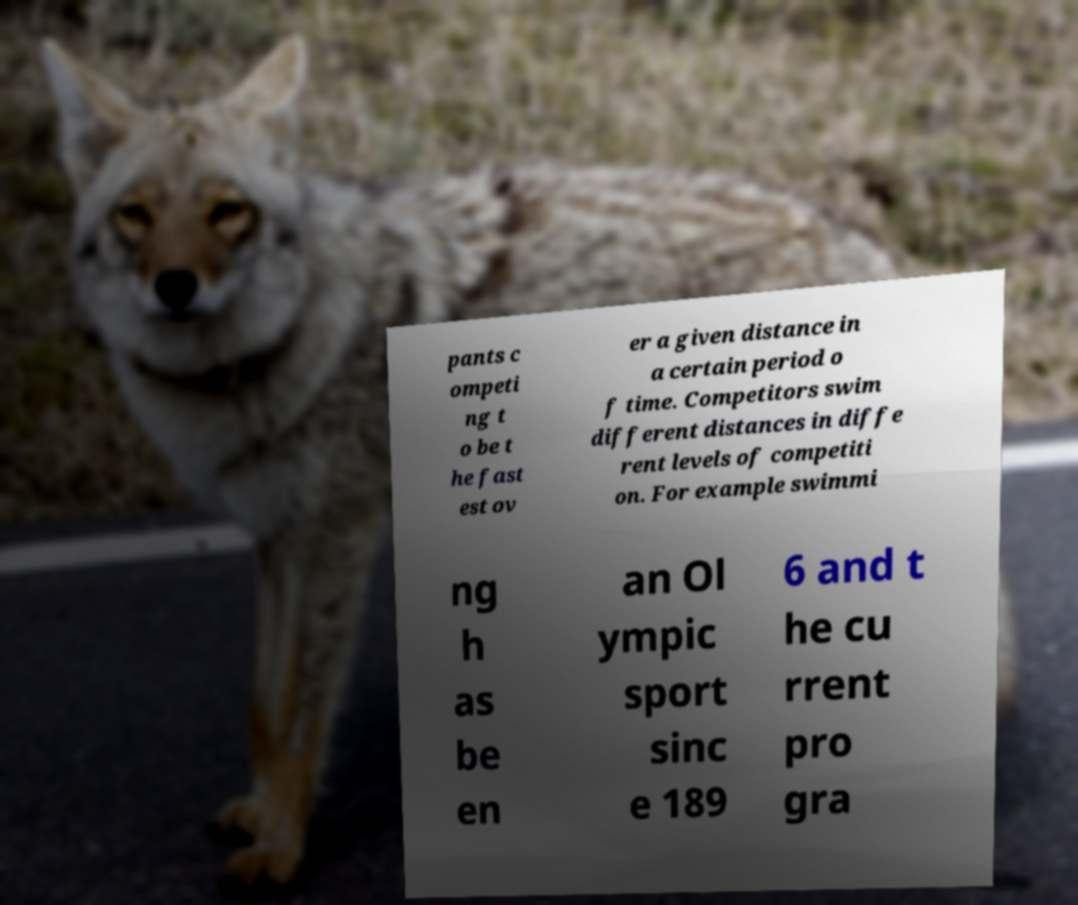Please read and relay the text visible in this image. What does it say? pants c ompeti ng t o be t he fast est ov er a given distance in a certain period o f time. Competitors swim different distances in diffe rent levels of competiti on. For example swimmi ng h as be en an Ol ympic sport sinc e 189 6 and t he cu rrent pro gra 